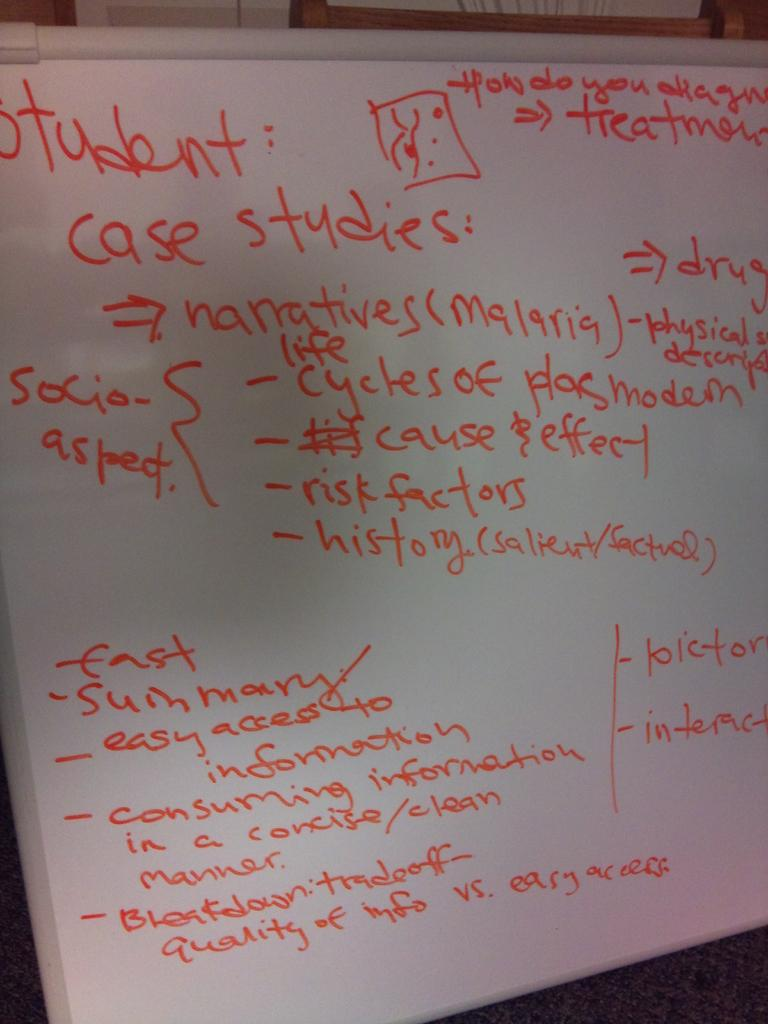<image>
Summarize the visual content of the image. A white board has a lesson plan written on it, including case studies and socio-aspect. 